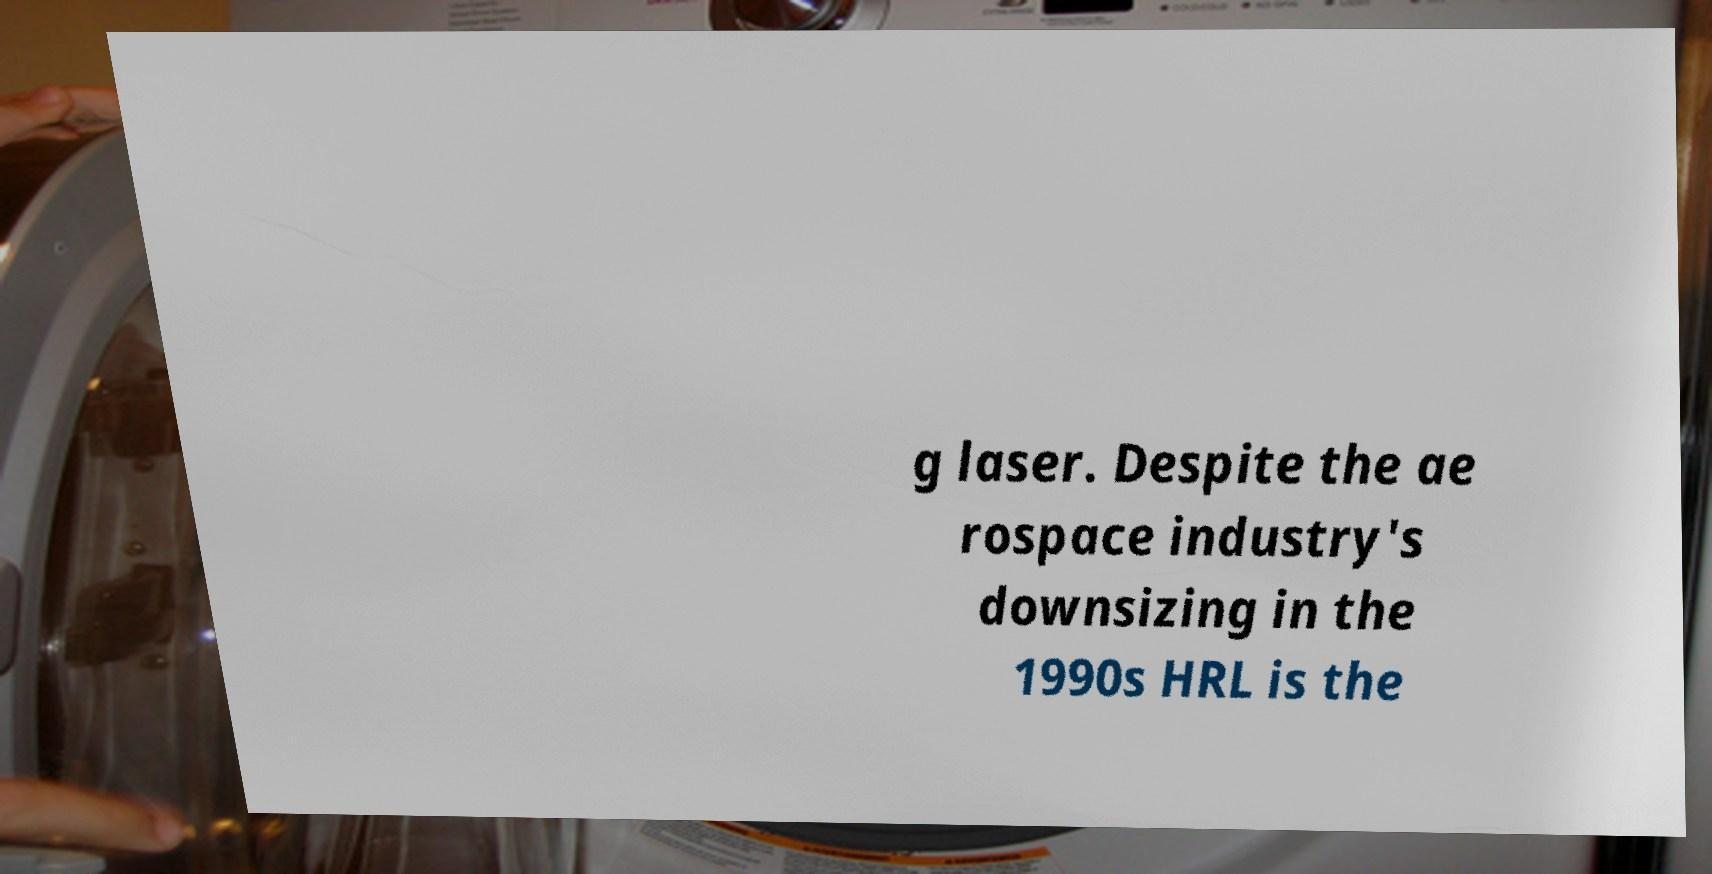Could you assist in decoding the text presented in this image and type it out clearly? g laser. Despite the ae rospace industry's downsizing in the 1990s HRL is the 